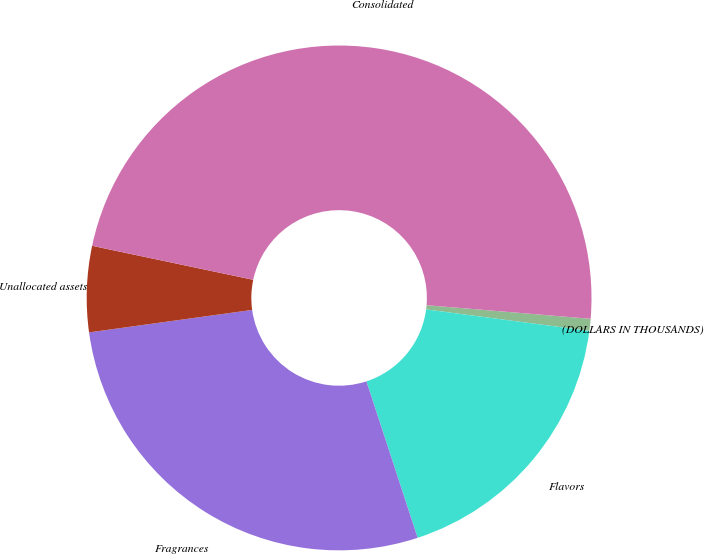Convert chart. <chart><loc_0><loc_0><loc_500><loc_500><pie_chart><fcel>(DOLLARS IN THOUSANDS)<fcel>Flavors<fcel>Fragrances<fcel>Unallocated assets<fcel>Consolidated<nl><fcel>0.77%<fcel>17.88%<fcel>27.86%<fcel>5.49%<fcel>48.01%<nl></chart> 